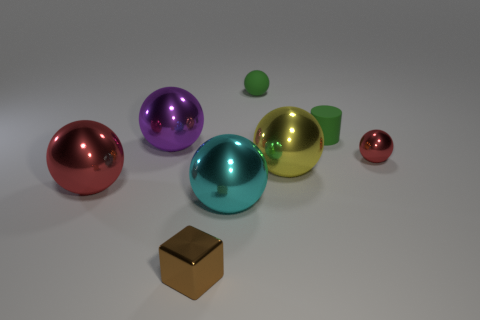Subtract all green spheres. How many spheres are left? 5 Subtract all red spheres. How many spheres are left? 4 Subtract all yellow spheres. Subtract all cyan blocks. How many spheres are left? 5 Add 1 big green balls. How many objects exist? 9 Subtract all blocks. How many objects are left? 7 Subtract 0 brown balls. How many objects are left? 8 Subtract all tiny green matte cylinders. Subtract all brown metal things. How many objects are left? 6 Add 5 big purple metal things. How many big purple metal things are left? 6 Add 2 small green rubber balls. How many small green rubber balls exist? 3 